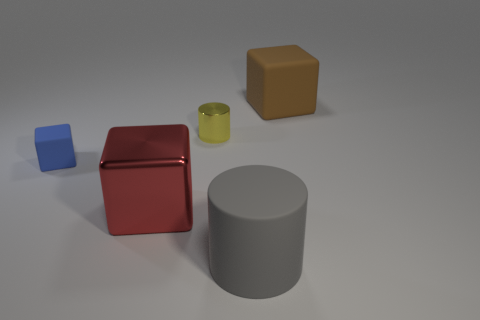How many small things are on the left side of the tiny metal cylinder?
Provide a short and direct response. 1. What is the material of the small yellow thing?
Your response must be concise. Metal. There is a large block in front of the large thing behind the metallic object to the left of the yellow thing; what is its color?
Ensure brevity in your answer.  Red. What number of blue rubber things are the same size as the yellow metallic cylinder?
Your answer should be compact. 1. What color is the rubber block that is to the left of the yellow metal object?
Your answer should be compact. Blue. How many other objects are the same size as the red shiny thing?
Provide a succinct answer. 2. There is a rubber object that is behind the red metal cube and in front of the small yellow shiny cylinder; what size is it?
Offer a very short reply. Small. Are there any large brown matte things of the same shape as the blue rubber thing?
Ensure brevity in your answer.  Yes. What number of objects are either large red rubber cylinders or matte blocks that are behind the small blue matte object?
Offer a very short reply. 1. How many other things are there of the same material as the tiny cylinder?
Provide a succinct answer. 1. 